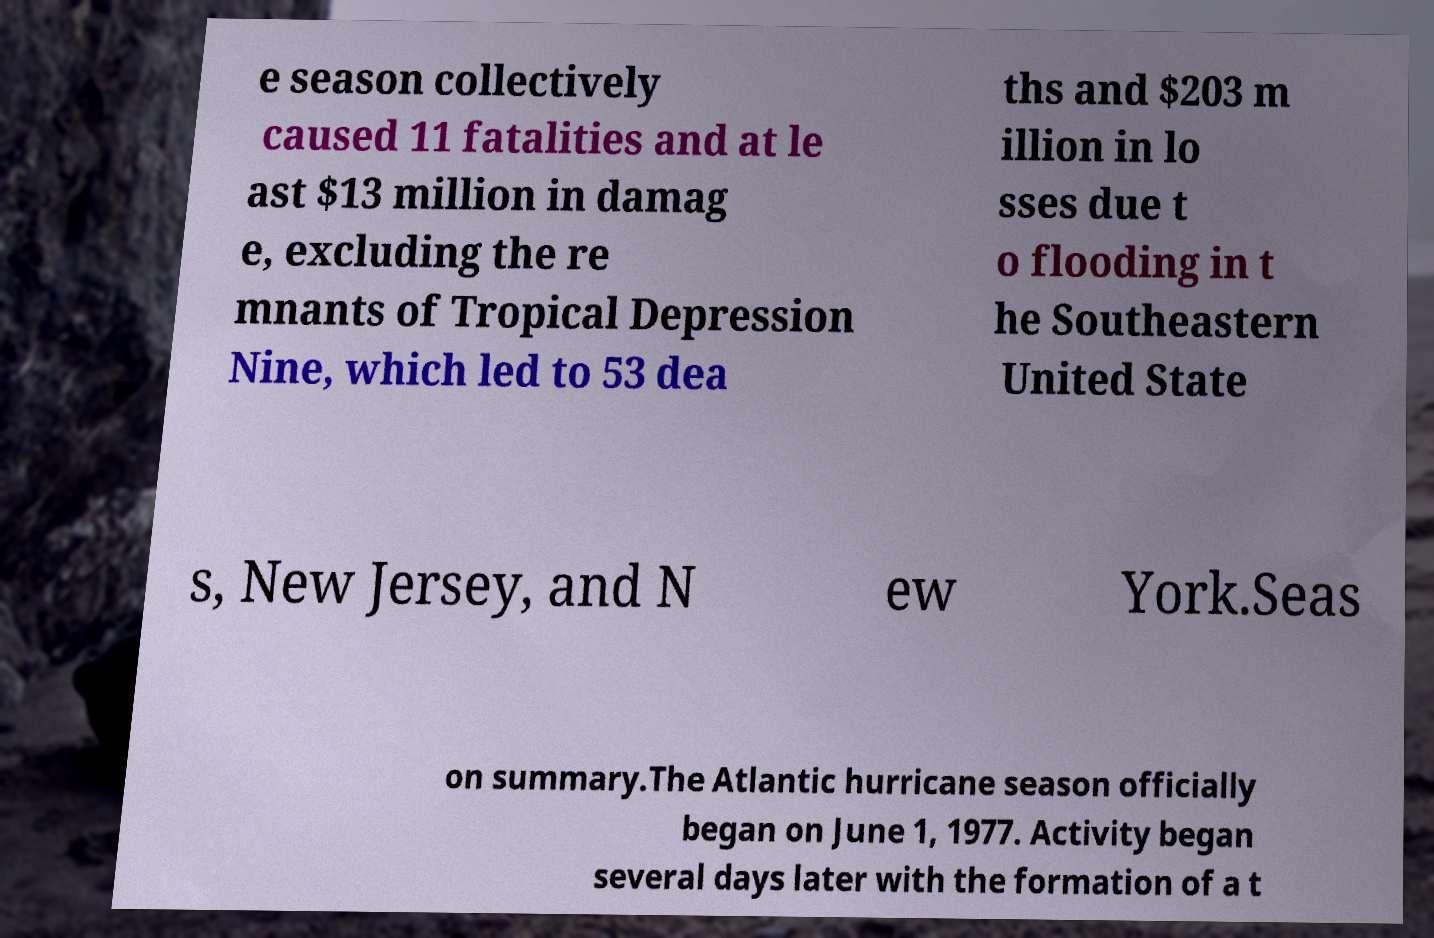Please identify and transcribe the text found in this image. e season collectively caused 11 fatalities and at le ast $13 million in damag e, excluding the re mnants of Tropical Depression Nine, which led to 53 dea ths and $203 m illion in lo sses due t o flooding in t he Southeastern United State s, New Jersey, and N ew York.Seas on summary.The Atlantic hurricane season officially began on June 1, 1977. Activity began several days later with the formation of a t 